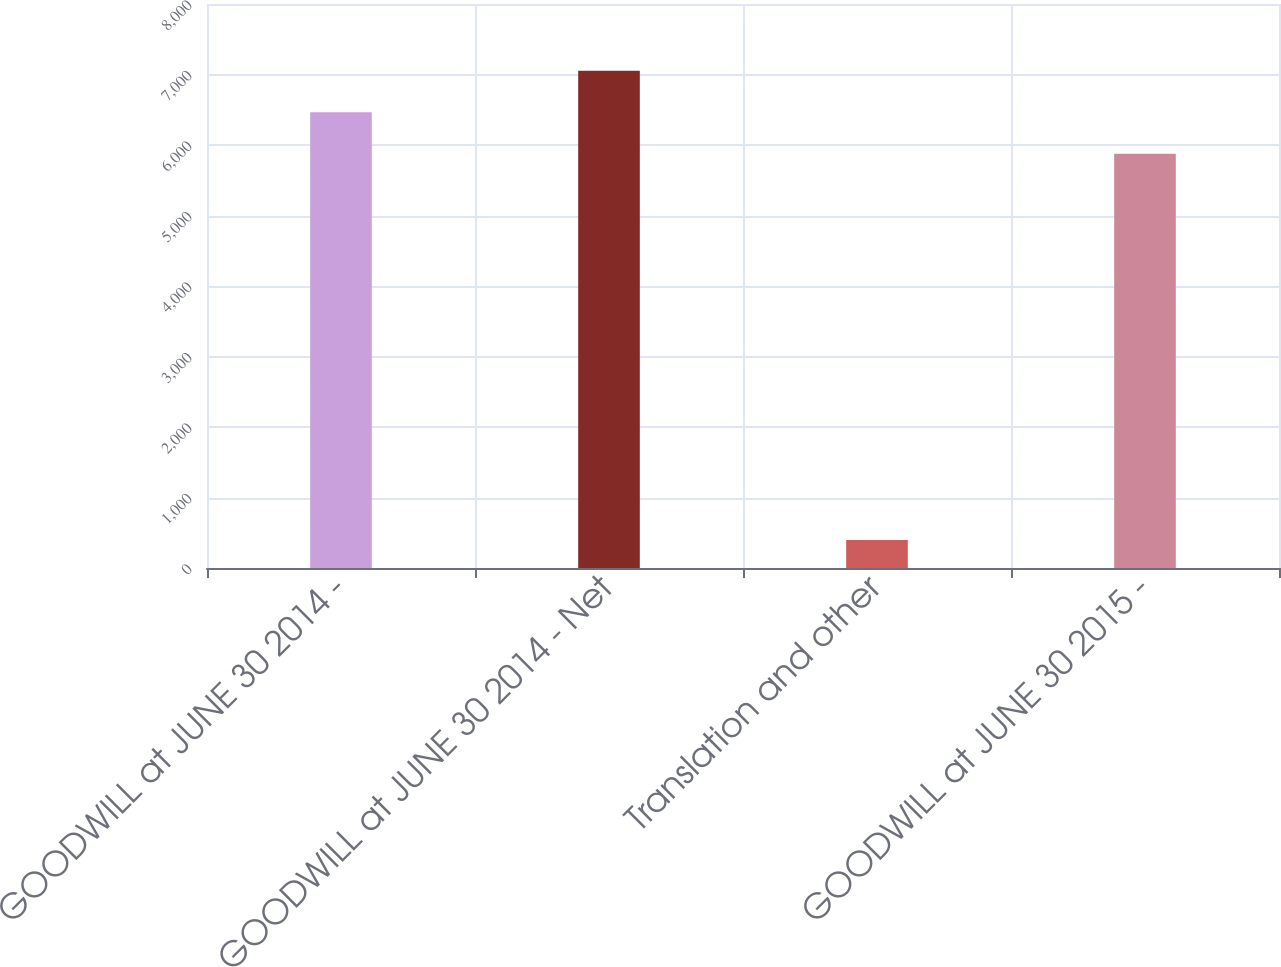<chart> <loc_0><loc_0><loc_500><loc_500><bar_chart><fcel>GOODWILL at JUNE 30 2014 -<fcel>GOODWILL at JUNE 30 2014 - Net<fcel>Translation and other<fcel>GOODWILL at JUNE 30 2015 -<nl><fcel>6464.2<fcel>7052.4<fcel>398<fcel>5876<nl></chart> 